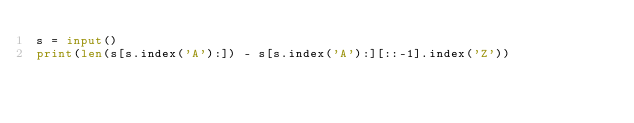Convert code to text. <code><loc_0><loc_0><loc_500><loc_500><_Python_>s = input()
print(len(s[s.index('A'):]) - s[s.index('A'):][::-1].index('Z'))</code> 